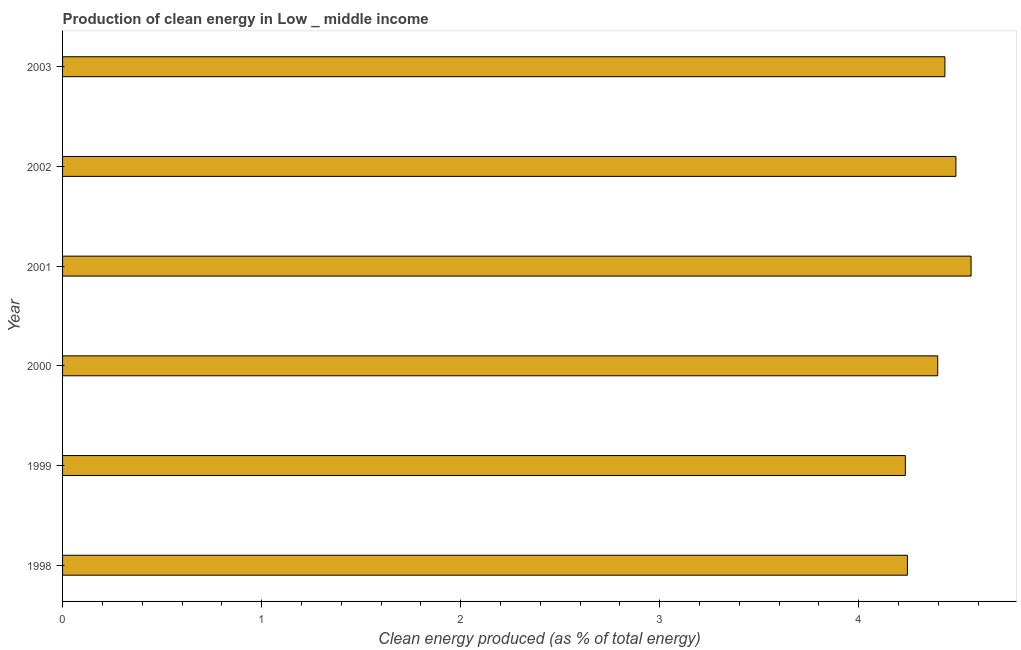Does the graph contain grids?
Your response must be concise. No. What is the title of the graph?
Your answer should be compact. Production of clean energy in Low _ middle income. What is the label or title of the X-axis?
Your response must be concise. Clean energy produced (as % of total energy). What is the label or title of the Y-axis?
Ensure brevity in your answer.  Year. What is the production of clean energy in 2000?
Provide a succinct answer. 4.4. Across all years, what is the maximum production of clean energy?
Ensure brevity in your answer.  4.56. Across all years, what is the minimum production of clean energy?
Keep it short and to the point. 4.23. In which year was the production of clean energy minimum?
Make the answer very short. 1999. What is the sum of the production of clean energy?
Make the answer very short. 26.36. What is the difference between the production of clean energy in 2002 and 2003?
Offer a terse response. 0.06. What is the average production of clean energy per year?
Make the answer very short. 4.39. What is the median production of clean energy?
Offer a terse response. 4.41. Do a majority of the years between 1998 and 2000 (inclusive) have production of clean energy greater than 3.2 %?
Keep it short and to the point. Yes. What is the ratio of the production of clean energy in 1998 to that in 2003?
Provide a short and direct response. 0.96. Is the production of clean energy in 1998 less than that in 2000?
Provide a short and direct response. Yes. Is the difference between the production of clean energy in 2000 and 2001 greater than the difference between any two years?
Give a very brief answer. No. What is the difference between the highest and the second highest production of clean energy?
Give a very brief answer. 0.08. What is the difference between the highest and the lowest production of clean energy?
Provide a succinct answer. 0.33. How many bars are there?
Offer a very short reply. 6. Are all the bars in the graph horizontal?
Your answer should be very brief. Yes. Are the values on the major ticks of X-axis written in scientific E-notation?
Your answer should be compact. No. What is the Clean energy produced (as % of total energy) in 1998?
Provide a succinct answer. 4.24. What is the Clean energy produced (as % of total energy) of 1999?
Provide a short and direct response. 4.23. What is the Clean energy produced (as % of total energy) in 2000?
Provide a succinct answer. 4.4. What is the Clean energy produced (as % of total energy) of 2001?
Offer a very short reply. 4.56. What is the Clean energy produced (as % of total energy) of 2002?
Provide a succinct answer. 4.49. What is the Clean energy produced (as % of total energy) in 2003?
Your answer should be compact. 4.43. What is the difference between the Clean energy produced (as % of total energy) in 1998 and 1999?
Offer a terse response. 0.01. What is the difference between the Clean energy produced (as % of total energy) in 1998 and 2000?
Your answer should be compact. -0.15. What is the difference between the Clean energy produced (as % of total energy) in 1998 and 2001?
Make the answer very short. -0.32. What is the difference between the Clean energy produced (as % of total energy) in 1998 and 2002?
Ensure brevity in your answer.  -0.24. What is the difference between the Clean energy produced (as % of total energy) in 1998 and 2003?
Ensure brevity in your answer.  -0.19. What is the difference between the Clean energy produced (as % of total energy) in 1999 and 2000?
Make the answer very short. -0.16. What is the difference between the Clean energy produced (as % of total energy) in 1999 and 2001?
Offer a very short reply. -0.33. What is the difference between the Clean energy produced (as % of total energy) in 1999 and 2002?
Your answer should be compact. -0.25. What is the difference between the Clean energy produced (as % of total energy) in 1999 and 2003?
Offer a terse response. -0.2. What is the difference between the Clean energy produced (as % of total energy) in 2000 and 2001?
Offer a very short reply. -0.17. What is the difference between the Clean energy produced (as % of total energy) in 2000 and 2002?
Give a very brief answer. -0.09. What is the difference between the Clean energy produced (as % of total energy) in 2000 and 2003?
Your answer should be compact. -0.04. What is the difference between the Clean energy produced (as % of total energy) in 2001 and 2002?
Keep it short and to the point. 0.08. What is the difference between the Clean energy produced (as % of total energy) in 2001 and 2003?
Keep it short and to the point. 0.13. What is the difference between the Clean energy produced (as % of total energy) in 2002 and 2003?
Provide a short and direct response. 0.06. What is the ratio of the Clean energy produced (as % of total energy) in 1998 to that in 1999?
Provide a succinct answer. 1. What is the ratio of the Clean energy produced (as % of total energy) in 1998 to that in 2002?
Provide a short and direct response. 0.95. What is the ratio of the Clean energy produced (as % of total energy) in 1998 to that in 2003?
Ensure brevity in your answer.  0.96. What is the ratio of the Clean energy produced (as % of total energy) in 1999 to that in 2000?
Provide a short and direct response. 0.96. What is the ratio of the Clean energy produced (as % of total energy) in 1999 to that in 2001?
Make the answer very short. 0.93. What is the ratio of the Clean energy produced (as % of total energy) in 1999 to that in 2002?
Offer a very short reply. 0.94. What is the ratio of the Clean energy produced (as % of total energy) in 1999 to that in 2003?
Provide a succinct answer. 0.95. What is the ratio of the Clean energy produced (as % of total energy) in 2001 to that in 2002?
Your answer should be very brief. 1.02. What is the ratio of the Clean energy produced (as % of total energy) in 2001 to that in 2003?
Keep it short and to the point. 1.03. What is the ratio of the Clean energy produced (as % of total energy) in 2002 to that in 2003?
Make the answer very short. 1.01. 